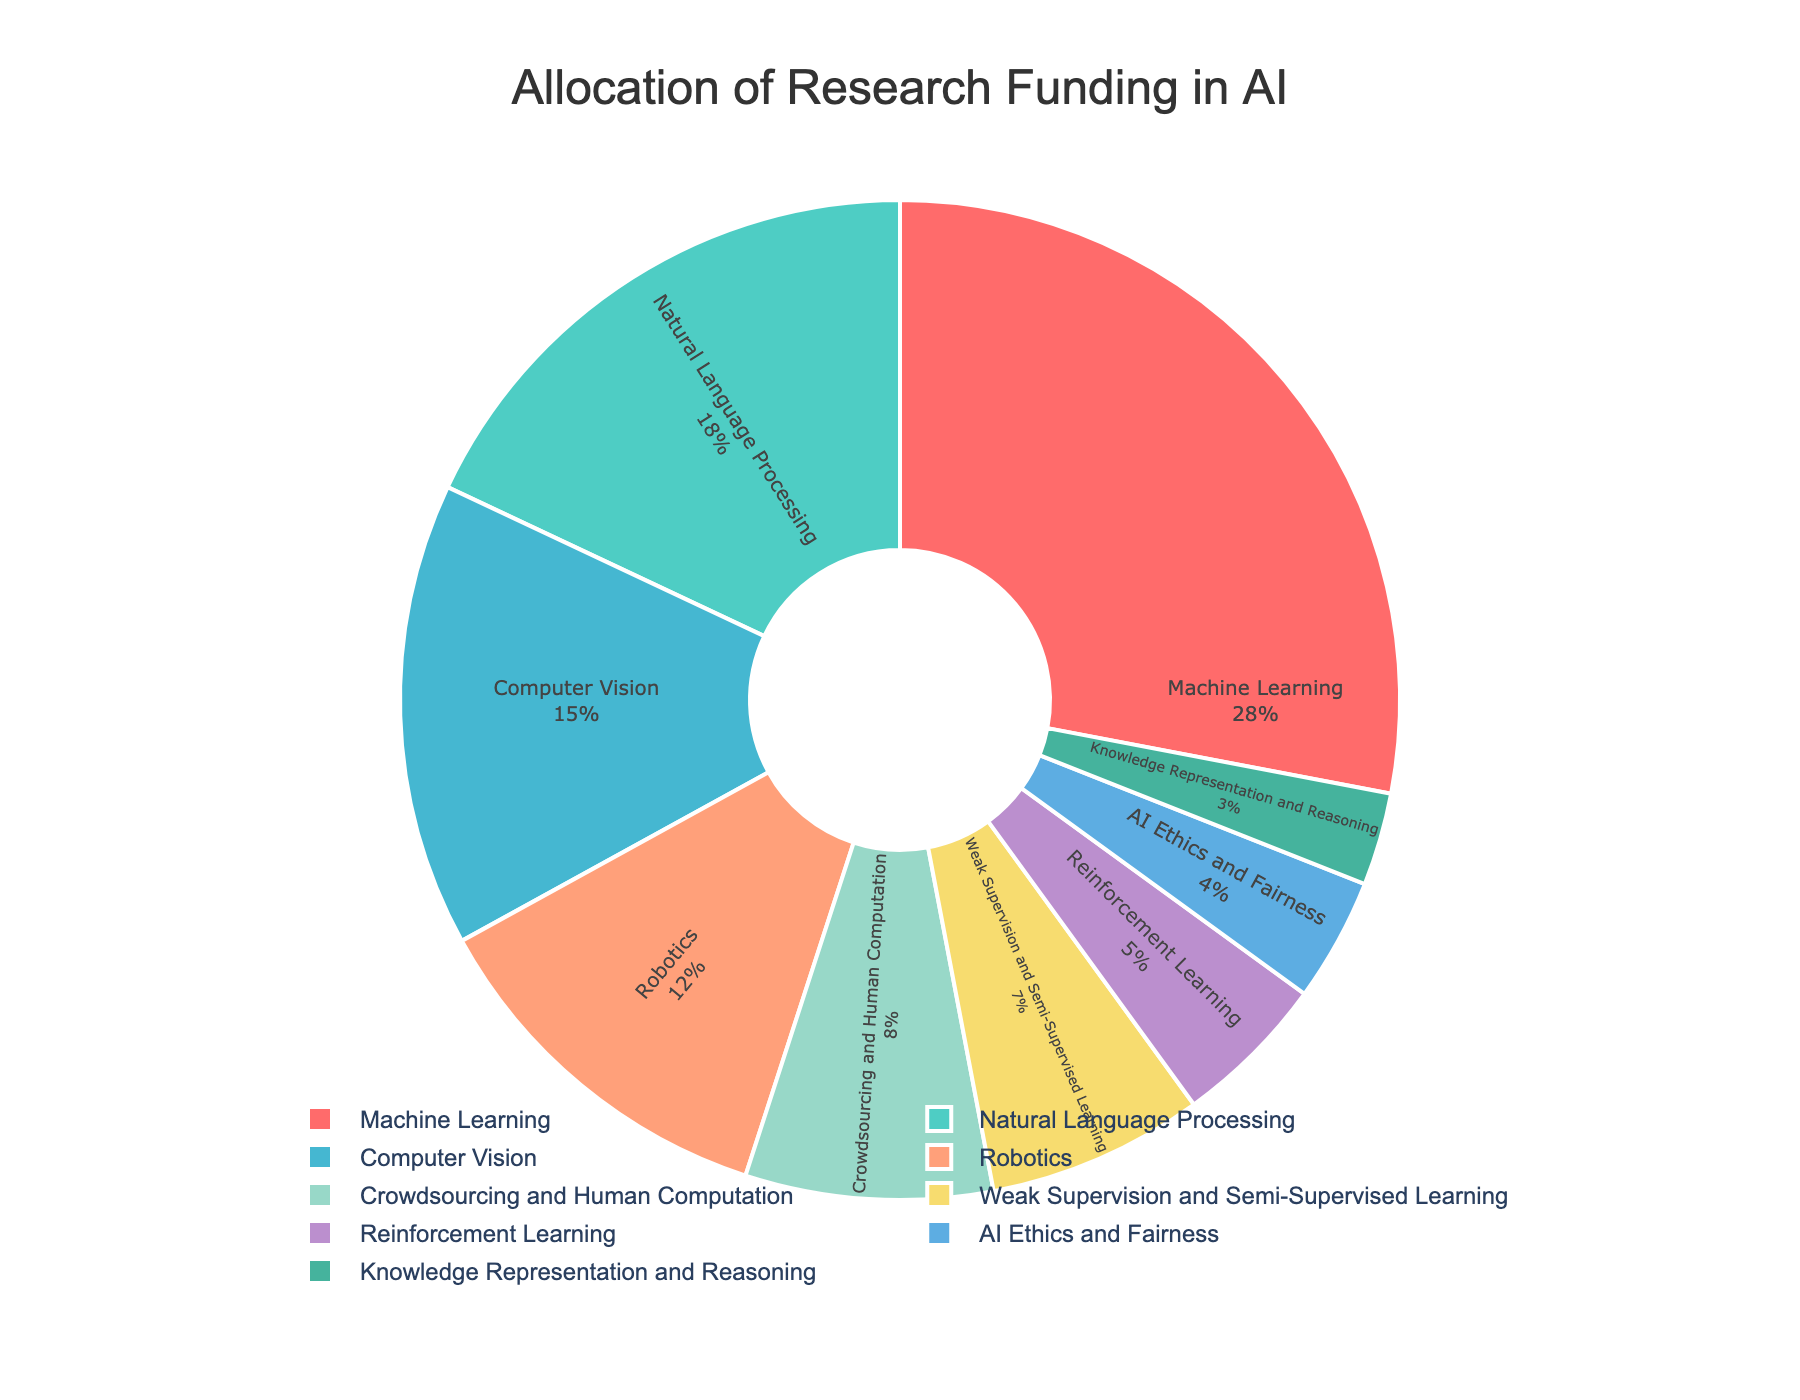What's the percentage of funding allocated to Machine Learning? The figure shows a pie chart where each slice represents an area within artificial intelligence. The slice for Machine Learning has a label indicating its percentage of funding. By checking the chart, we see Machine Learning is allocated 28% of the funding.
Answer: 28% Which area has the lowest percentage of research funding? The figure shows various areas with their corresponding funding percentages. The smallest slice in the pie chart represents Knowledge Representation and Reasoning, which has the label indicating 3% funding.
Answer: Knowledge Representation and Reasoning Is the funding for Natural Language Processing greater than that for Computer Vision? The figure shows the funding percentages for both Natural Language Processing (18%) and Computer Vision (15%). Since 18% is greater than 15%, the funding for Natural Language Processing is greater.
Answer: Yes What's the combined funding percentage for Robotics and AI Ethics and Fairness? The figure shows the funding percentages for Robotics (12%) and AI Ethics and Fairness (4%). Adding these together gives 16%.
Answer: 16% Compare the funding allocation between Crowdsourcing and Human Computation and Weak Supervision and Semi-Supervised Learning. Which area receives more funding and by how much? The pie chart shows funding for Crowdsourcing and Human Computation at 8% and for Weak Supervision and Semi-Supervised Learning at 7%. The difference is 8% - 7% = 1%.
Answer: Crowdsourcing and Human Computation, by 1% What color represents Reinforcement Learning? The pie chart uses different colors for each area. By identifying the slice labeled Reinforcement Learning, we see it is colored light purple.
Answer: Light Purple What is the percentage difference in funding between Machine Learning and Natural Language Processing? The pie chart shows Machine Learning receives 28% and Natural Language Processing gets 18%. The difference is 28% - 18% = 10%.
Answer: 10% What's the total funding percentage for areas with less than 10% allocation each? The areas with less than 10% allocation are Crowdsourcing and Human Computation (8%), Weak Supervision and Semi-Supervised Learning (7%), Reinforcement Learning (5%), AI Ethics and Fairness (4%), and Knowledge Representation and Reasoning (3%). Adding these percentages: 8% + 7% + 5% + 4% + 3% = 27%.
Answer: 27% 